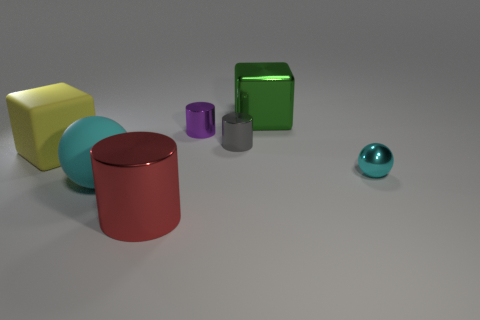Add 3 large cyan matte things. How many objects exist? 10 Subtract all balls. How many objects are left? 5 Add 5 big balls. How many big balls exist? 6 Subtract 0 gray balls. How many objects are left? 7 Subtract all small cyan metal things. Subtract all small green cylinders. How many objects are left? 6 Add 2 small cyan objects. How many small cyan objects are left? 3 